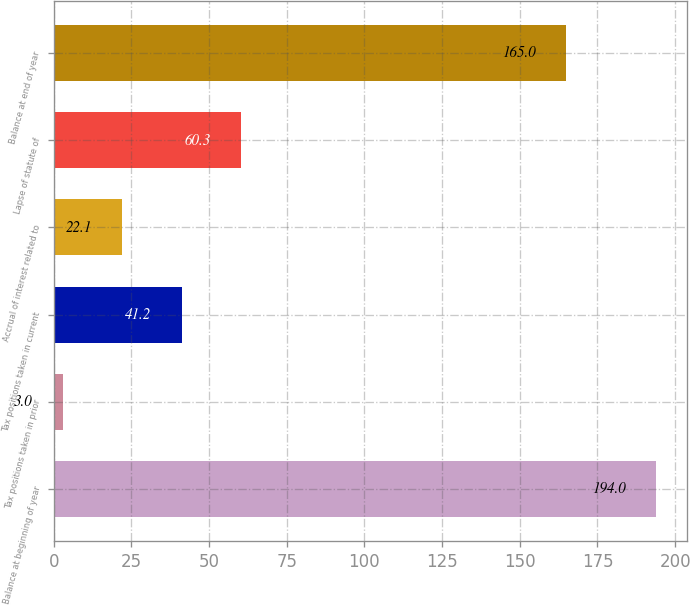<chart> <loc_0><loc_0><loc_500><loc_500><bar_chart><fcel>Balance at beginning of year<fcel>Tax positions taken in prior<fcel>Tax positions taken in current<fcel>Accrual of interest related to<fcel>Lapse of statute of<fcel>Balance at end of year<nl><fcel>194<fcel>3<fcel>41.2<fcel>22.1<fcel>60.3<fcel>165<nl></chart> 